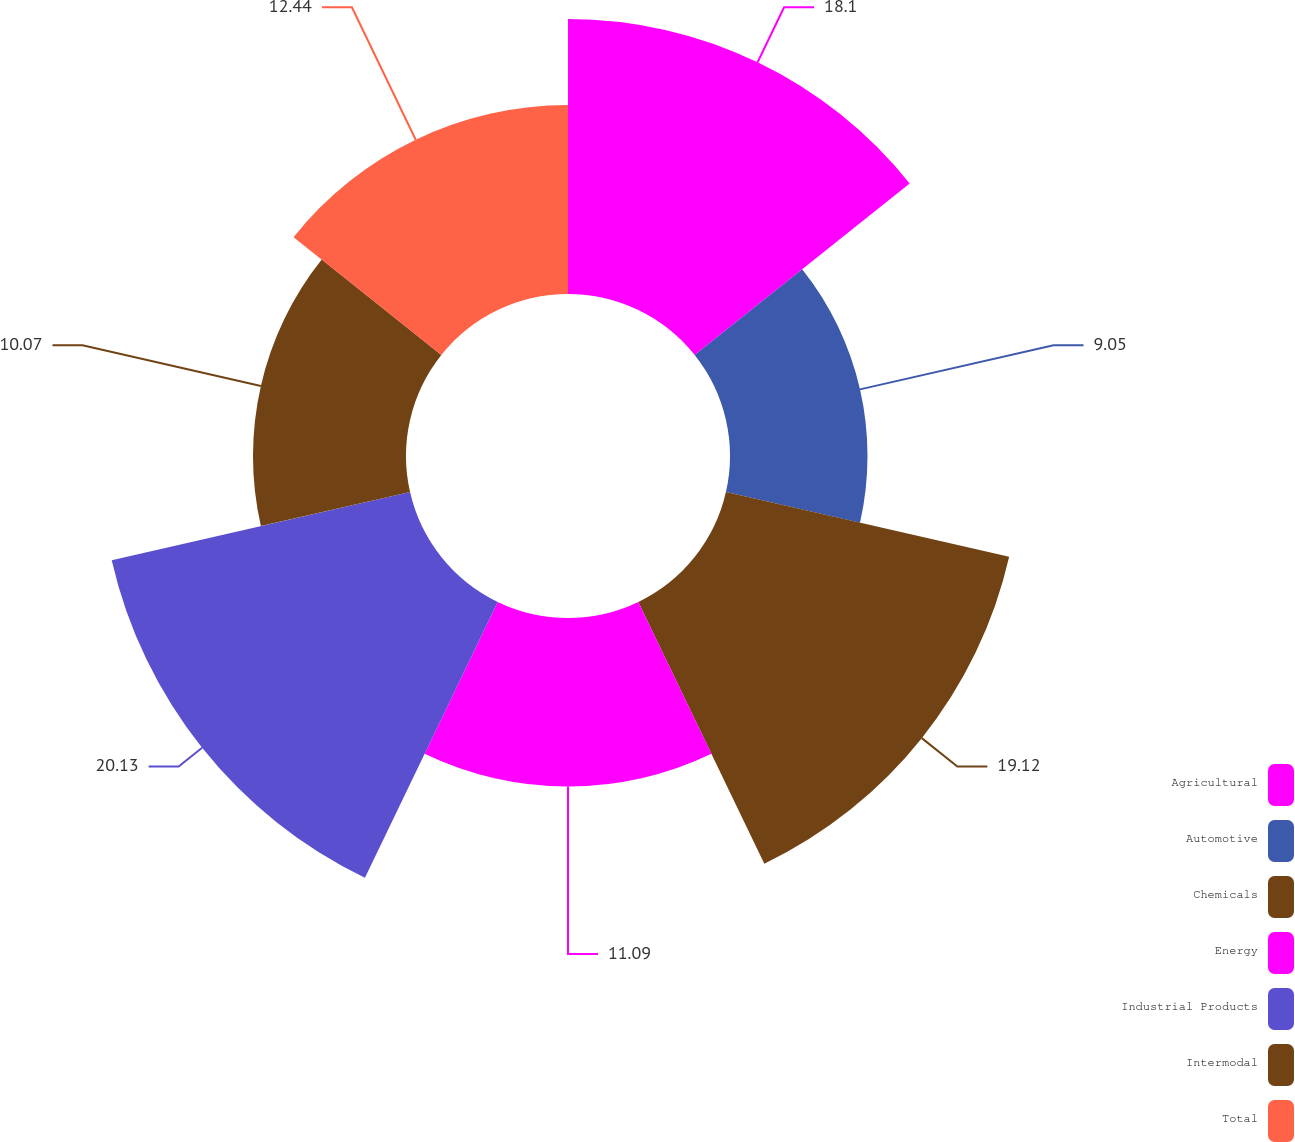<chart> <loc_0><loc_0><loc_500><loc_500><pie_chart><fcel>Agricultural<fcel>Automotive<fcel>Chemicals<fcel>Energy<fcel>Industrial Products<fcel>Intermodal<fcel>Total<nl><fcel>18.1%<fcel>9.05%<fcel>19.12%<fcel>11.09%<fcel>20.14%<fcel>10.07%<fcel>12.44%<nl></chart> 